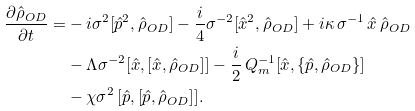<formula> <loc_0><loc_0><loc_500><loc_500>\frac { \partial \hat { \rho } _ { O D } } { \partial t } = & - i \sigma ^ { 2 } [ \hat { p } ^ { 2 } , \hat { \rho } _ { O D } ] - \frac { i } { 4 } \sigma ^ { - 2 } [ \hat { x } ^ { 2 } , \hat { \rho } _ { O D } ] + i \kappa \, \sigma ^ { - 1 } \, \hat { x } \, \hat { \rho } _ { O D } \\ & - \Lambda \sigma ^ { - 2 } [ \hat { x } , [ \hat { x } , \hat { \rho } _ { O D } ] ] - \frac { i } { 2 } \, Q _ { m } ^ { - 1 } [ \hat { x } , \{ \hat { p } , \hat { \rho } _ { O D } \} ] \\ & - \chi \sigma ^ { 2 } \, [ \hat { p } , [ \hat { p } , \hat { \rho } _ { O D } ] ] .</formula> 